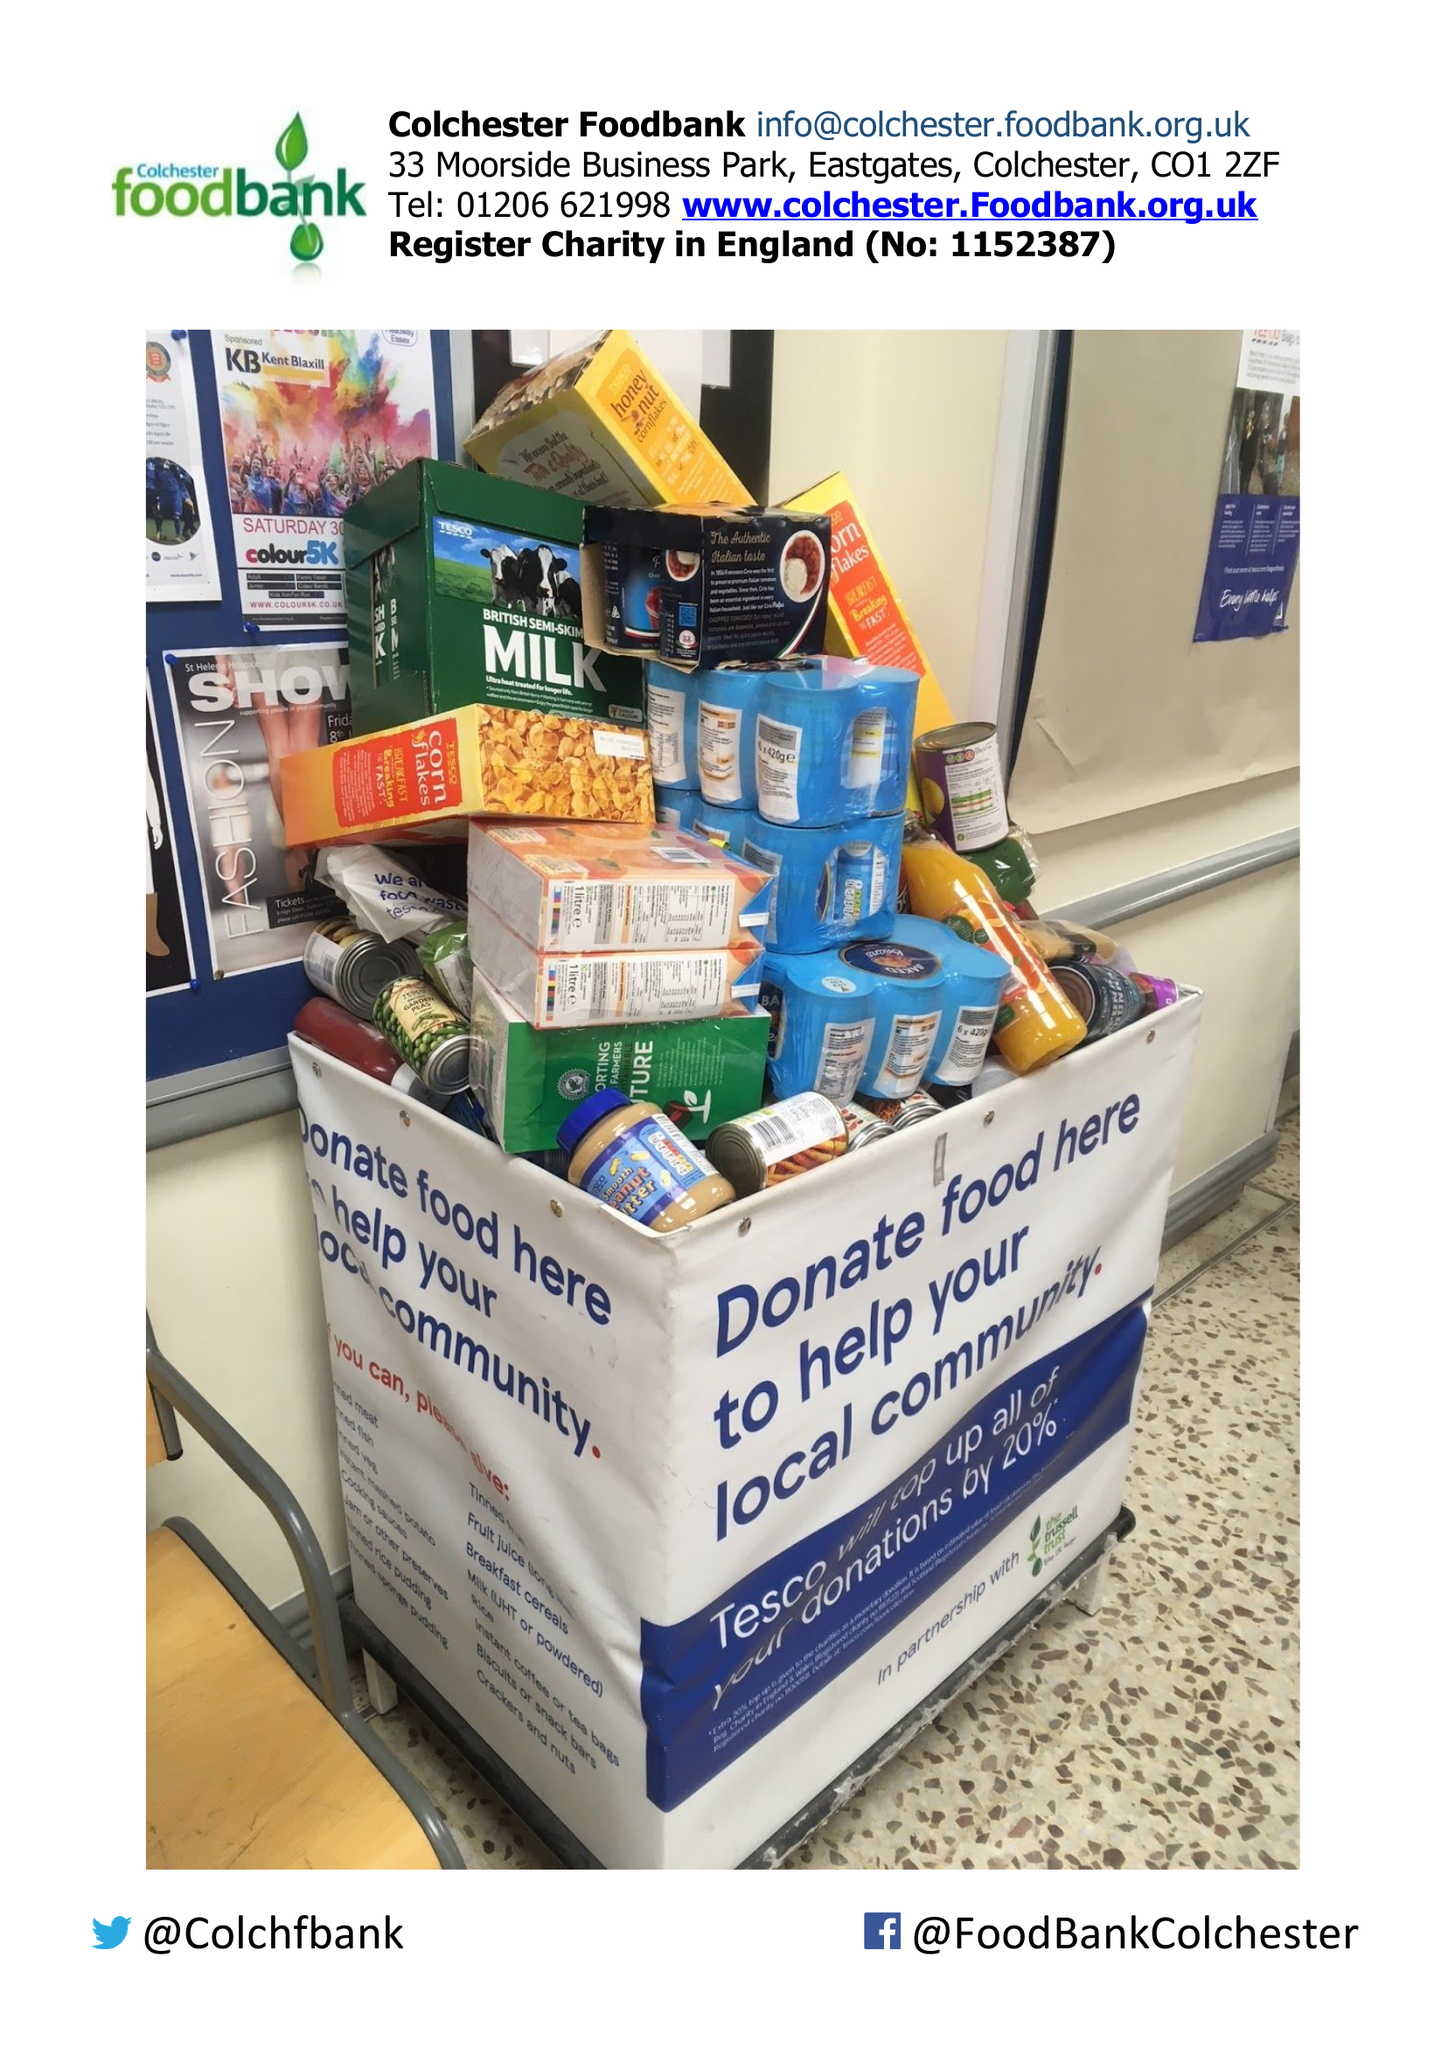What is the value for the address__postcode?
Answer the question using a single word or phrase. CO4 3UY 